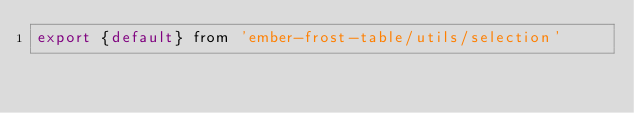Convert code to text. <code><loc_0><loc_0><loc_500><loc_500><_JavaScript_>export {default} from 'ember-frost-table/utils/selection'
</code> 